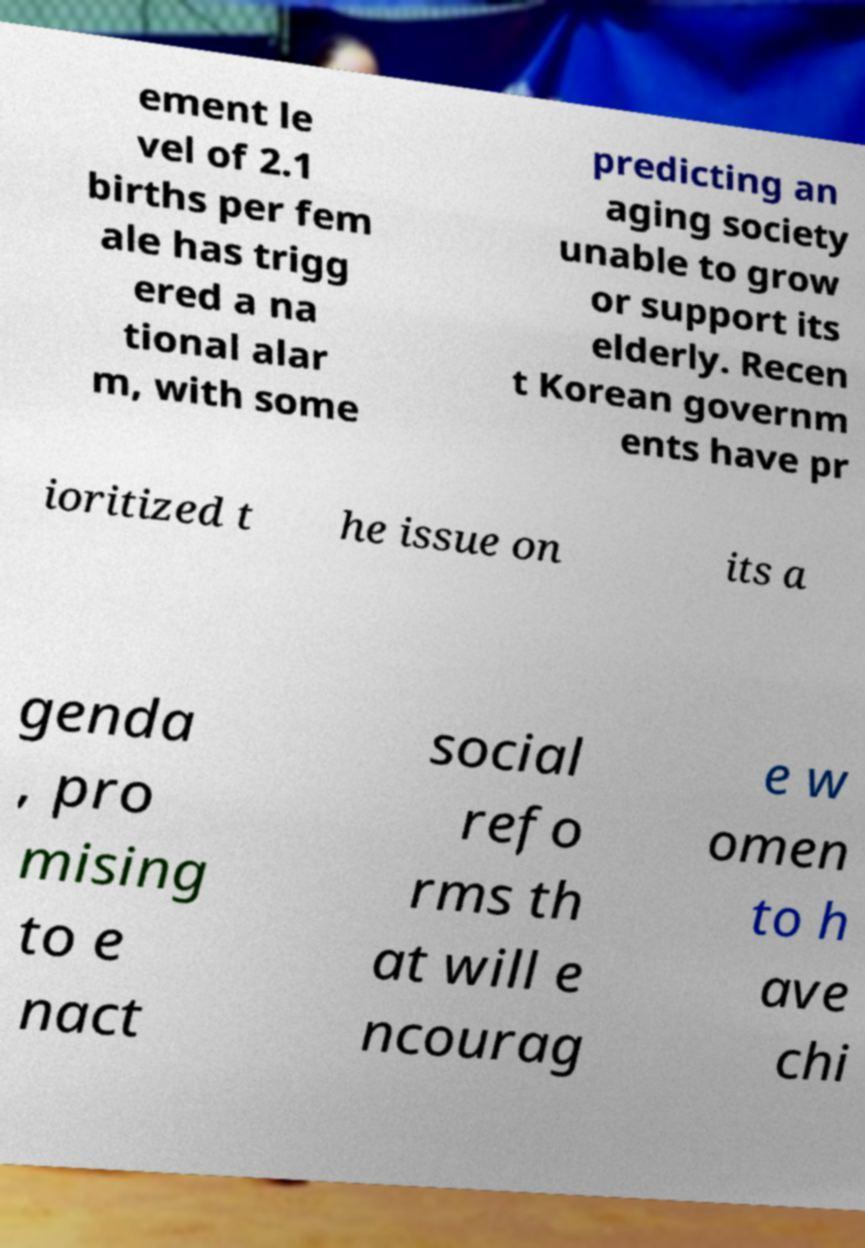Can you accurately transcribe the text from the provided image for me? ement le vel of 2.1 births per fem ale has trigg ered a na tional alar m, with some predicting an aging society unable to grow or support its elderly. Recen t Korean governm ents have pr ioritized t he issue on its a genda , pro mising to e nact social refo rms th at will e ncourag e w omen to h ave chi 